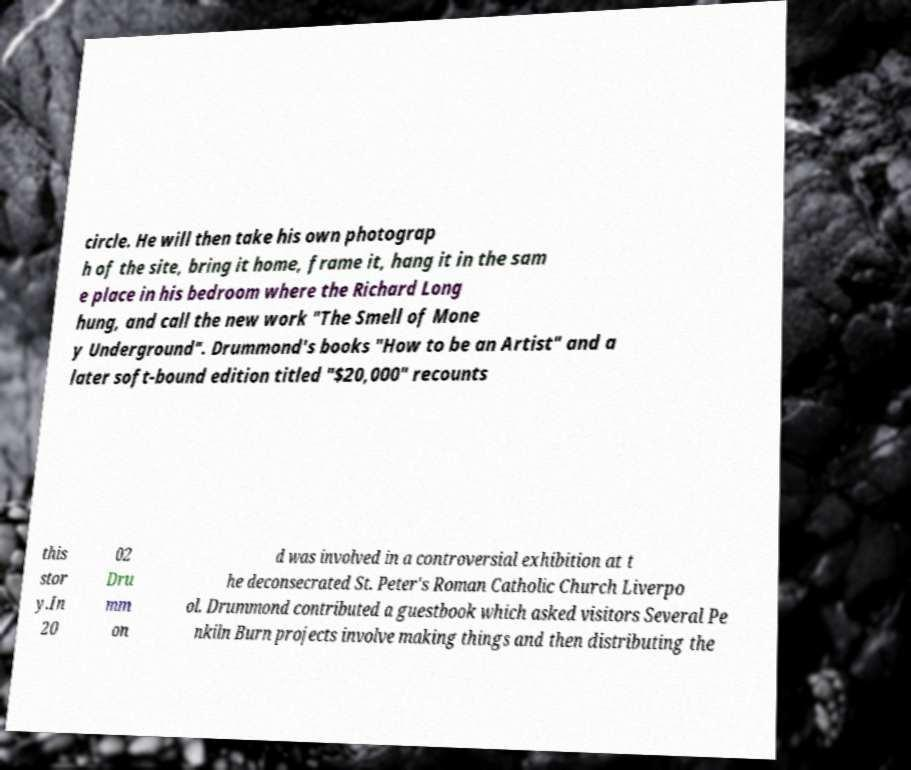For documentation purposes, I need the text within this image transcribed. Could you provide that? circle. He will then take his own photograp h of the site, bring it home, frame it, hang it in the sam e place in his bedroom where the Richard Long hung, and call the new work "The Smell of Mone y Underground". Drummond's books "How to be an Artist" and a later soft-bound edition titled "$20,000" recounts this stor y.In 20 02 Dru mm on d was involved in a controversial exhibition at t he deconsecrated St. Peter's Roman Catholic Church Liverpo ol. Drummond contributed a guestbook which asked visitors Several Pe nkiln Burn projects involve making things and then distributing the 